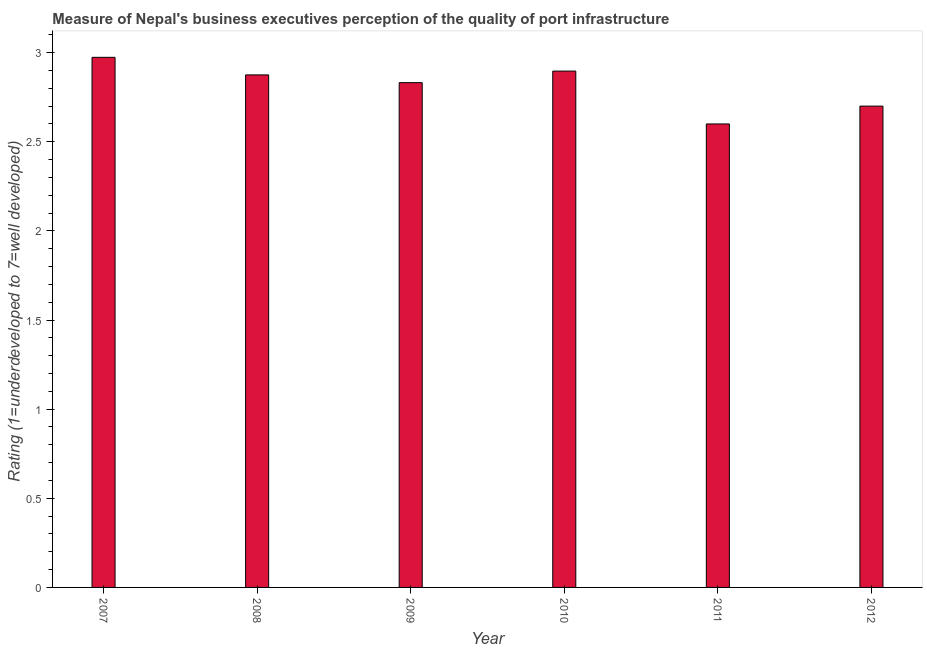Does the graph contain any zero values?
Keep it short and to the point. No. Does the graph contain grids?
Provide a short and direct response. No. What is the title of the graph?
Keep it short and to the point. Measure of Nepal's business executives perception of the quality of port infrastructure. What is the label or title of the Y-axis?
Offer a terse response. Rating (1=underdeveloped to 7=well developed) . What is the rating measuring quality of port infrastructure in 2009?
Keep it short and to the point. 2.83. Across all years, what is the maximum rating measuring quality of port infrastructure?
Provide a succinct answer. 2.97. Across all years, what is the minimum rating measuring quality of port infrastructure?
Offer a terse response. 2.6. What is the sum of the rating measuring quality of port infrastructure?
Provide a succinct answer. 16.88. What is the difference between the rating measuring quality of port infrastructure in 2007 and 2012?
Give a very brief answer. 0.27. What is the average rating measuring quality of port infrastructure per year?
Your answer should be compact. 2.81. What is the median rating measuring quality of port infrastructure?
Offer a very short reply. 2.85. In how many years, is the rating measuring quality of port infrastructure greater than 0.5 ?
Keep it short and to the point. 6. What is the ratio of the rating measuring quality of port infrastructure in 2008 to that in 2010?
Your response must be concise. 0.99. Is the rating measuring quality of port infrastructure in 2008 less than that in 2011?
Make the answer very short. No. Is the difference between the rating measuring quality of port infrastructure in 2007 and 2010 greater than the difference between any two years?
Offer a terse response. No. What is the difference between the highest and the second highest rating measuring quality of port infrastructure?
Provide a short and direct response. 0.08. Is the sum of the rating measuring quality of port infrastructure in 2009 and 2011 greater than the maximum rating measuring quality of port infrastructure across all years?
Your response must be concise. Yes. What is the difference between the highest and the lowest rating measuring quality of port infrastructure?
Provide a succinct answer. 0.37. In how many years, is the rating measuring quality of port infrastructure greater than the average rating measuring quality of port infrastructure taken over all years?
Keep it short and to the point. 4. How many years are there in the graph?
Your answer should be compact. 6. What is the difference between two consecutive major ticks on the Y-axis?
Keep it short and to the point. 0.5. Are the values on the major ticks of Y-axis written in scientific E-notation?
Provide a short and direct response. No. What is the Rating (1=underdeveloped to 7=well developed)  of 2007?
Your response must be concise. 2.97. What is the Rating (1=underdeveloped to 7=well developed)  in 2008?
Keep it short and to the point. 2.88. What is the Rating (1=underdeveloped to 7=well developed)  of 2009?
Your response must be concise. 2.83. What is the Rating (1=underdeveloped to 7=well developed)  of 2010?
Give a very brief answer. 2.9. What is the difference between the Rating (1=underdeveloped to 7=well developed)  in 2007 and 2008?
Provide a short and direct response. 0.1. What is the difference between the Rating (1=underdeveloped to 7=well developed)  in 2007 and 2009?
Your answer should be very brief. 0.14. What is the difference between the Rating (1=underdeveloped to 7=well developed)  in 2007 and 2010?
Your answer should be compact. 0.08. What is the difference between the Rating (1=underdeveloped to 7=well developed)  in 2007 and 2011?
Keep it short and to the point. 0.37. What is the difference between the Rating (1=underdeveloped to 7=well developed)  in 2007 and 2012?
Your answer should be very brief. 0.27. What is the difference between the Rating (1=underdeveloped to 7=well developed)  in 2008 and 2009?
Keep it short and to the point. 0.04. What is the difference between the Rating (1=underdeveloped to 7=well developed)  in 2008 and 2010?
Provide a succinct answer. -0.02. What is the difference between the Rating (1=underdeveloped to 7=well developed)  in 2008 and 2011?
Provide a succinct answer. 0.28. What is the difference between the Rating (1=underdeveloped to 7=well developed)  in 2008 and 2012?
Your answer should be very brief. 0.18. What is the difference between the Rating (1=underdeveloped to 7=well developed)  in 2009 and 2010?
Provide a succinct answer. -0.06. What is the difference between the Rating (1=underdeveloped to 7=well developed)  in 2009 and 2011?
Ensure brevity in your answer.  0.23. What is the difference between the Rating (1=underdeveloped to 7=well developed)  in 2009 and 2012?
Your answer should be compact. 0.13. What is the difference between the Rating (1=underdeveloped to 7=well developed)  in 2010 and 2011?
Keep it short and to the point. 0.3. What is the difference between the Rating (1=underdeveloped to 7=well developed)  in 2010 and 2012?
Your answer should be compact. 0.2. What is the ratio of the Rating (1=underdeveloped to 7=well developed)  in 2007 to that in 2008?
Your answer should be compact. 1.03. What is the ratio of the Rating (1=underdeveloped to 7=well developed)  in 2007 to that in 2009?
Provide a short and direct response. 1.05. What is the ratio of the Rating (1=underdeveloped to 7=well developed)  in 2007 to that in 2011?
Ensure brevity in your answer.  1.14. What is the ratio of the Rating (1=underdeveloped to 7=well developed)  in 2007 to that in 2012?
Give a very brief answer. 1.1. What is the ratio of the Rating (1=underdeveloped to 7=well developed)  in 2008 to that in 2011?
Offer a very short reply. 1.11. What is the ratio of the Rating (1=underdeveloped to 7=well developed)  in 2008 to that in 2012?
Offer a very short reply. 1.06. What is the ratio of the Rating (1=underdeveloped to 7=well developed)  in 2009 to that in 2010?
Give a very brief answer. 0.98. What is the ratio of the Rating (1=underdeveloped to 7=well developed)  in 2009 to that in 2011?
Offer a terse response. 1.09. What is the ratio of the Rating (1=underdeveloped to 7=well developed)  in 2009 to that in 2012?
Keep it short and to the point. 1.05. What is the ratio of the Rating (1=underdeveloped to 7=well developed)  in 2010 to that in 2011?
Your answer should be compact. 1.11. What is the ratio of the Rating (1=underdeveloped to 7=well developed)  in 2010 to that in 2012?
Offer a terse response. 1.07. What is the ratio of the Rating (1=underdeveloped to 7=well developed)  in 2011 to that in 2012?
Make the answer very short. 0.96. 